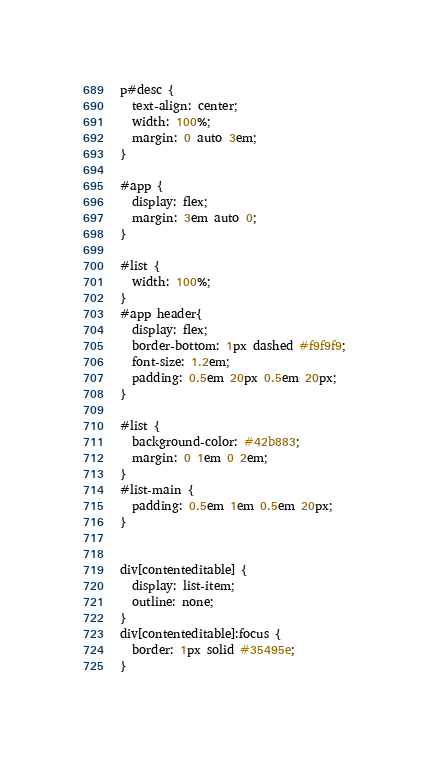<code> <loc_0><loc_0><loc_500><loc_500><_CSS_>p#desc {
  text-align: center;
  width: 100%;
  margin: 0 auto 3em;
}

#app {
  display: flex;
  margin: 3em auto 0;
}

#list {
  width: 100%;
}
#app header{
  display: flex;
  border-bottom: 1px dashed #f9f9f9;
  font-size: 1.2em;
  padding: 0.5em 20px 0.5em 20px;
}

#list {
  background-color: #42b883;
  margin: 0 1em 0 2em;
}
#list-main {
  padding: 0.5em 1em 0.5em 20px;
}


div[contenteditable] {
  display: list-item;
  outline: none;
}
div[contenteditable]:focus {
  border: 1px solid #35495e;
}
</code> 